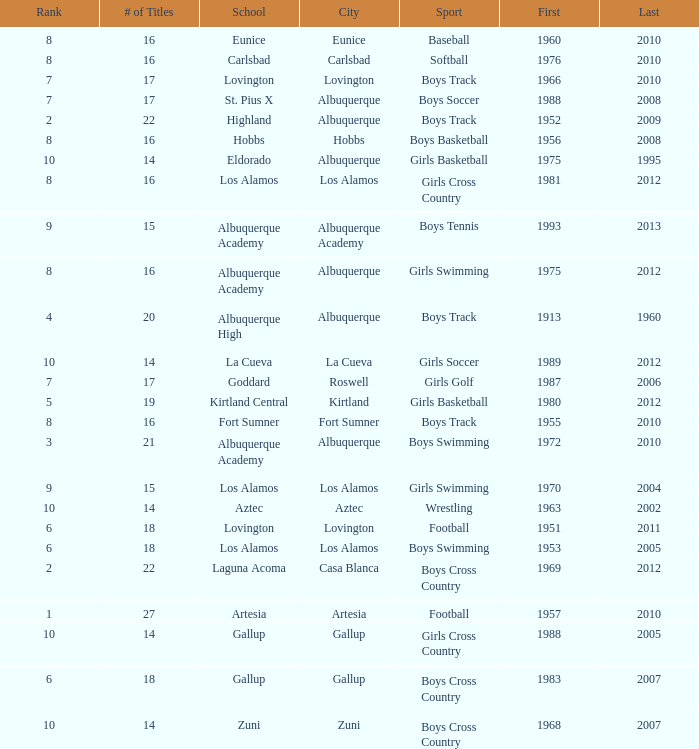What city is the school that had less than 17 titles in boys basketball with the last title being after 2005? Hobbs. 